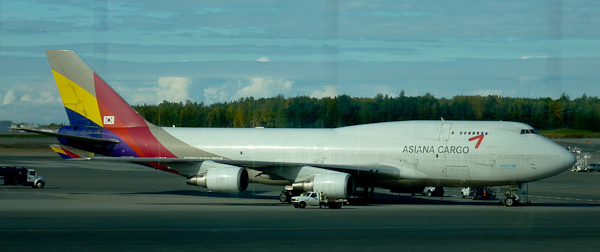<image>What type of leaf is on the tail of the planes? I am not sure. It can either be maple, elm or no leaf at all. What type of leaf is on the tail of the planes? I am not sure what type of leaf is on the tail of the planes. It can be seen 'maple', 'elm', 'colorful' or 'none'. 